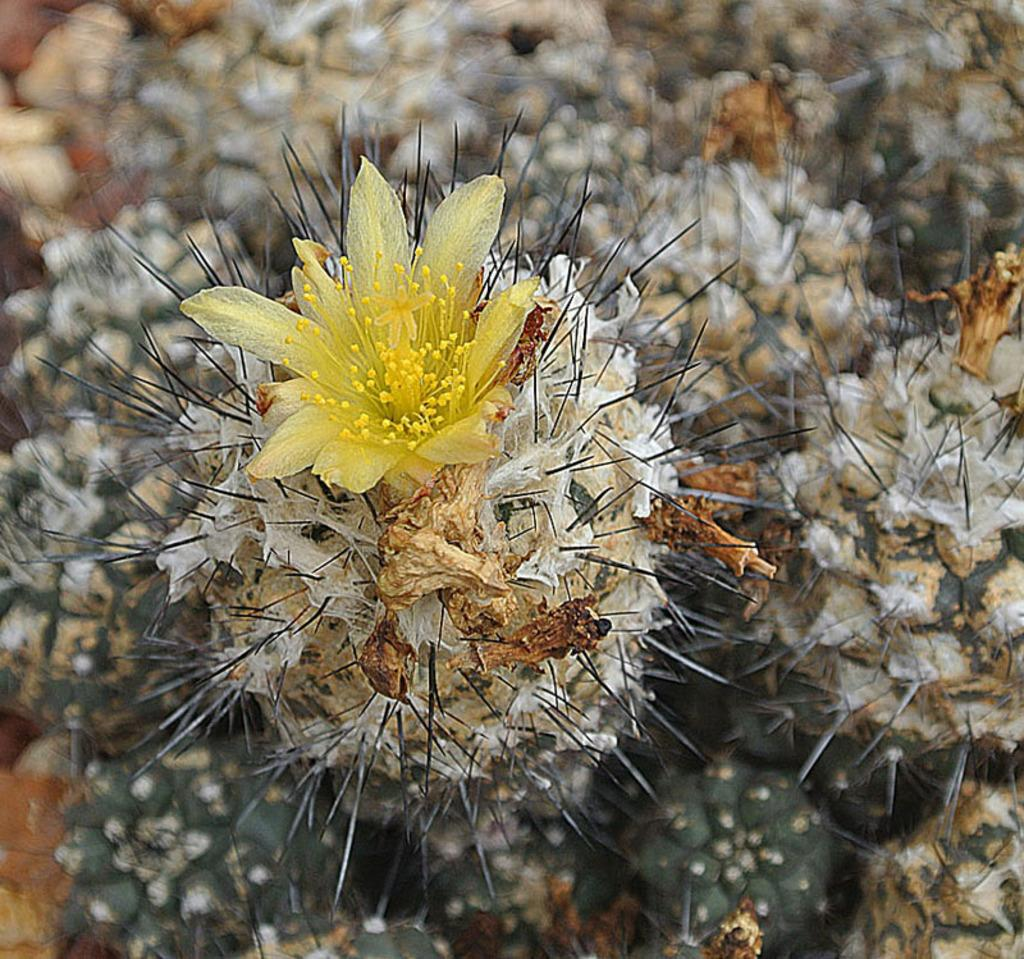What type of plants are in the image? There are cactus plants in the image. What additional feature can be observed on the cactus plants? The cactus plants have flowers. Can you tell me how many doors are visible in the image? There are no doors present in the image; it features cactus plants with flowers. What type of animal can be seen slithering among the cactus plants in the image? There are no animals, including snakes, visible in the image. 